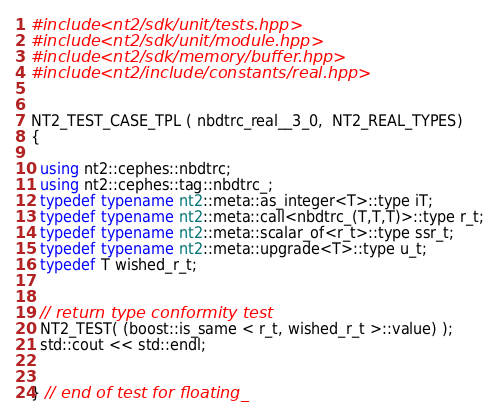Convert code to text. <code><loc_0><loc_0><loc_500><loc_500><_C++_>#include <nt2/sdk/unit/tests.hpp>
#include <nt2/sdk/unit/module.hpp>
#include <nt2/sdk/memory/buffer.hpp>
#include <nt2/include/constants/real.hpp>


NT2_TEST_CASE_TPL ( nbdtrc_real__3_0,  NT2_REAL_TYPES)
{

  using nt2::cephes::nbdtrc;
  using nt2::cephes::tag::nbdtrc_;
  typedef typename nt2::meta::as_integer<T>::type iT;
  typedef typename nt2::meta::call<nbdtrc_(T,T,T)>::type r_t;
  typedef typename nt2::meta::scalar_of<r_t>::type ssr_t;
  typedef typename nt2::meta::upgrade<T>::type u_t;
  typedef T wished_r_t;


  // return type conformity test
  NT2_TEST( (boost::is_same < r_t, wished_r_t >::value) );
  std::cout << std::endl;


} // end of test for floating_
</code> 